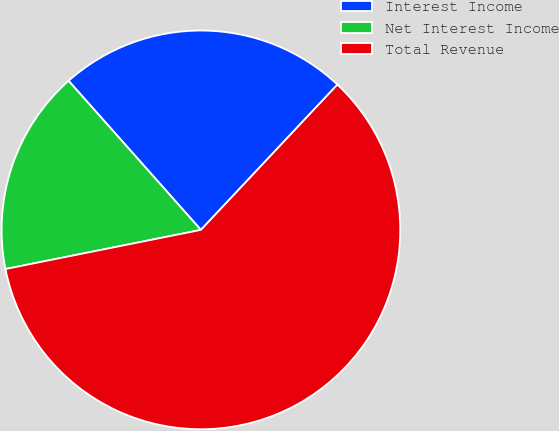Convert chart. <chart><loc_0><loc_0><loc_500><loc_500><pie_chart><fcel>Interest Income<fcel>Net Interest Income<fcel>Total Revenue<nl><fcel>23.56%<fcel>16.59%<fcel>59.85%<nl></chart> 